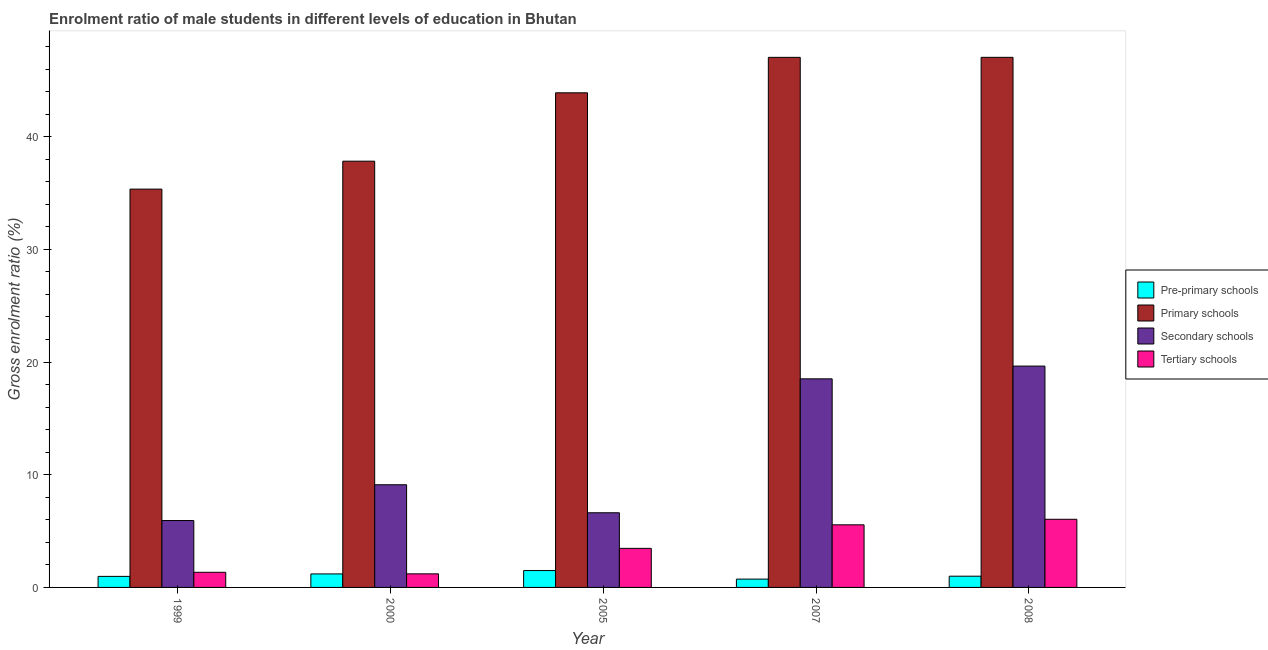How many different coloured bars are there?
Offer a terse response. 4. How many groups of bars are there?
Give a very brief answer. 5. Are the number of bars per tick equal to the number of legend labels?
Offer a terse response. Yes. Are the number of bars on each tick of the X-axis equal?
Provide a succinct answer. Yes. How many bars are there on the 5th tick from the right?
Ensure brevity in your answer.  4. What is the label of the 5th group of bars from the left?
Your response must be concise. 2008. In how many cases, is the number of bars for a given year not equal to the number of legend labels?
Offer a very short reply. 0. What is the gross enrolment ratio(female) in tertiary schools in 2005?
Keep it short and to the point. 3.47. Across all years, what is the maximum gross enrolment ratio(female) in primary schools?
Keep it short and to the point. 47.04. Across all years, what is the minimum gross enrolment ratio(female) in secondary schools?
Make the answer very short. 5.94. What is the total gross enrolment ratio(female) in tertiary schools in the graph?
Offer a terse response. 17.62. What is the difference between the gross enrolment ratio(female) in primary schools in 2005 and that in 2007?
Your response must be concise. -3.15. What is the difference between the gross enrolment ratio(female) in primary schools in 1999 and the gross enrolment ratio(female) in tertiary schools in 2000?
Your response must be concise. -2.48. What is the average gross enrolment ratio(female) in pre-primary schools per year?
Your answer should be very brief. 1.08. In the year 1999, what is the difference between the gross enrolment ratio(female) in pre-primary schools and gross enrolment ratio(female) in secondary schools?
Provide a short and direct response. 0. In how many years, is the gross enrolment ratio(female) in primary schools greater than 34 %?
Your answer should be very brief. 5. What is the ratio of the gross enrolment ratio(female) in secondary schools in 2005 to that in 2008?
Give a very brief answer. 0.34. Is the gross enrolment ratio(female) in secondary schools in 2005 less than that in 2007?
Offer a terse response. Yes. Is the difference between the gross enrolment ratio(female) in tertiary schools in 1999 and 2005 greater than the difference between the gross enrolment ratio(female) in secondary schools in 1999 and 2005?
Your answer should be compact. No. What is the difference between the highest and the second highest gross enrolment ratio(female) in pre-primary schools?
Provide a succinct answer. 0.3. What is the difference between the highest and the lowest gross enrolment ratio(female) in pre-primary schools?
Your answer should be very brief. 0.76. In how many years, is the gross enrolment ratio(female) in tertiary schools greater than the average gross enrolment ratio(female) in tertiary schools taken over all years?
Your answer should be compact. 2. Is the sum of the gross enrolment ratio(female) in primary schools in 2005 and 2008 greater than the maximum gross enrolment ratio(female) in tertiary schools across all years?
Your response must be concise. Yes. Is it the case that in every year, the sum of the gross enrolment ratio(female) in pre-primary schools and gross enrolment ratio(female) in tertiary schools is greater than the sum of gross enrolment ratio(female) in secondary schools and gross enrolment ratio(female) in primary schools?
Keep it short and to the point. No. What does the 3rd bar from the left in 1999 represents?
Offer a very short reply. Secondary schools. What does the 3rd bar from the right in 2000 represents?
Make the answer very short. Primary schools. Are all the bars in the graph horizontal?
Keep it short and to the point. No. Are the values on the major ticks of Y-axis written in scientific E-notation?
Offer a very short reply. No. Does the graph contain any zero values?
Provide a succinct answer. No. Does the graph contain grids?
Provide a short and direct response. No. How are the legend labels stacked?
Keep it short and to the point. Vertical. What is the title of the graph?
Offer a very short reply. Enrolment ratio of male students in different levels of education in Bhutan. What is the Gross enrolment ratio (%) in Pre-primary schools in 1999?
Your response must be concise. 0.98. What is the Gross enrolment ratio (%) of Primary schools in 1999?
Provide a succinct answer. 35.35. What is the Gross enrolment ratio (%) of Secondary schools in 1999?
Offer a terse response. 5.94. What is the Gross enrolment ratio (%) of Tertiary schools in 1999?
Provide a short and direct response. 1.34. What is the Gross enrolment ratio (%) of Pre-primary schools in 2000?
Provide a succinct answer. 1.2. What is the Gross enrolment ratio (%) of Primary schools in 2000?
Provide a short and direct response. 37.83. What is the Gross enrolment ratio (%) in Secondary schools in 2000?
Your response must be concise. 9.11. What is the Gross enrolment ratio (%) of Tertiary schools in 2000?
Offer a terse response. 1.2. What is the Gross enrolment ratio (%) of Pre-primary schools in 2005?
Keep it short and to the point. 1.5. What is the Gross enrolment ratio (%) of Primary schools in 2005?
Ensure brevity in your answer.  43.89. What is the Gross enrolment ratio (%) in Secondary schools in 2005?
Your answer should be very brief. 6.63. What is the Gross enrolment ratio (%) in Tertiary schools in 2005?
Your response must be concise. 3.47. What is the Gross enrolment ratio (%) in Pre-primary schools in 2007?
Provide a succinct answer. 0.74. What is the Gross enrolment ratio (%) in Primary schools in 2007?
Provide a short and direct response. 47.04. What is the Gross enrolment ratio (%) of Secondary schools in 2007?
Make the answer very short. 18.51. What is the Gross enrolment ratio (%) of Tertiary schools in 2007?
Provide a short and direct response. 5.56. What is the Gross enrolment ratio (%) in Pre-primary schools in 2008?
Provide a short and direct response. 1. What is the Gross enrolment ratio (%) of Primary schools in 2008?
Give a very brief answer. 47.04. What is the Gross enrolment ratio (%) in Secondary schools in 2008?
Provide a succinct answer. 19.64. What is the Gross enrolment ratio (%) of Tertiary schools in 2008?
Keep it short and to the point. 6.05. Across all years, what is the maximum Gross enrolment ratio (%) of Pre-primary schools?
Keep it short and to the point. 1.5. Across all years, what is the maximum Gross enrolment ratio (%) of Primary schools?
Keep it short and to the point. 47.04. Across all years, what is the maximum Gross enrolment ratio (%) of Secondary schools?
Keep it short and to the point. 19.64. Across all years, what is the maximum Gross enrolment ratio (%) of Tertiary schools?
Provide a succinct answer. 6.05. Across all years, what is the minimum Gross enrolment ratio (%) in Pre-primary schools?
Keep it short and to the point. 0.74. Across all years, what is the minimum Gross enrolment ratio (%) of Primary schools?
Ensure brevity in your answer.  35.35. Across all years, what is the minimum Gross enrolment ratio (%) in Secondary schools?
Give a very brief answer. 5.94. Across all years, what is the minimum Gross enrolment ratio (%) in Tertiary schools?
Your answer should be compact. 1.2. What is the total Gross enrolment ratio (%) of Pre-primary schools in the graph?
Offer a very short reply. 5.41. What is the total Gross enrolment ratio (%) in Primary schools in the graph?
Your answer should be compact. 211.14. What is the total Gross enrolment ratio (%) in Secondary schools in the graph?
Keep it short and to the point. 59.82. What is the total Gross enrolment ratio (%) of Tertiary schools in the graph?
Make the answer very short. 17.62. What is the difference between the Gross enrolment ratio (%) in Pre-primary schools in 1999 and that in 2000?
Provide a succinct answer. -0.22. What is the difference between the Gross enrolment ratio (%) in Primary schools in 1999 and that in 2000?
Your answer should be compact. -2.48. What is the difference between the Gross enrolment ratio (%) of Secondary schools in 1999 and that in 2000?
Your response must be concise. -3.18. What is the difference between the Gross enrolment ratio (%) of Tertiary schools in 1999 and that in 2000?
Offer a very short reply. 0.14. What is the difference between the Gross enrolment ratio (%) in Pre-primary schools in 1999 and that in 2005?
Your response must be concise. -0.52. What is the difference between the Gross enrolment ratio (%) in Primary schools in 1999 and that in 2005?
Offer a very short reply. -8.55. What is the difference between the Gross enrolment ratio (%) of Secondary schools in 1999 and that in 2005?
Give a very brief answer. -0.69. What is the difference between the Gross enrolment ratio (%) in Tertiary schools in 1999 and that in 2005?
Provide a short and direct response. -2.12. What is the difference between the Gross enrolment ratio (%) of Pre-primary schools in 1999 and that in 2007?
Your answer should be compact. 0.24. What is the difference between the Gross enrolment ratio (%) of Primary schools in 1999 and that in 2007?
Your answer should be very brief. -11.69. What is the difference between the Gross enrolment ratio (%) of Secondary schools in 1999 and that in 2007?
Your response must be concise. -12.57. What is the difference between the Gross enrolment ratio (%) in Tertiary schools in 1999 and that in 2007?
Ensure brevity in your answer.  -4.21. What is the difference between the Gross enrolment ratio (%) of Pre-primary schools in 1999 and that in 2008?
Keep it short and to the point. -0.02. What is the difference between the Gross enrolment ratio (%) of Primary schools in 1999 and that in 2008?
Your response must be concise. -11.69. What is the difference between the Gross enrolment ratio (%) in Secondary schools in 1999 and that in 2008?
Provide a succinct answer. -13.71. What is the difference between the Gross enrolment ratio (%) in Tertiary schools in 1999 and that in 2008?
Give a very brief answer. -4.71. What is the difference between the Gross enrolment ratio (%) of Pre-primary schools in 2000 and that in 2005?
Provide a succinct answer. -0.3. What is the difference between the Gross enrolment ratio (%) in Primary schools in 2000 and that in 2005?
Provide a succinct answer. -6.07. What is the difference between the Gross enrolment ratio (%) in Secondary schools in 2000 and that in 2005?
Offer a very short reply. 2.49. What is the difference between the Gross enrolment ratio (%) of Tertiary schools in 2000 and that in 2005?
Your answer should be compact. -2.26. What is the difference between the Gross enrolment ratio (%) of Pre-primary schools in 2000 and that in 2007?
Offer a very short reply. 0.46. What is the difference between the Gross enrolment ratio (%) in Primary schools in 2000 and that in 2007?
Keep it short and to the point. -9.21. What is the difference between the Gross enrolment ratio (%) in Secondary schools in 2000 and that in 2007?
Your response must be concise. -9.4. What is the difference between the Gross enrolment ratio (%) of Tertiary schools in 2000 and that in 2007?
Provide a succinct answer. -4.35. What is the difference between the Gross enrolment ratio (%) in Pre-primary schools in 2000 and that in 2008?
Your response must be concise. 0.2. What is the difference between the Gross enrolment ratio (%) of Primary schools in 2000 and that in 2008?
Your answer should be compact. -9.21. What is the difference between the Gross enrolment ratio (%) in Secondary schools in 2000 and that in 2008?
Ensure brevity in your answer.  -10.53. What is the difference between the Gross enrolment ratio (%) in Tertiary schools in 2000 and that in 2008?
Your answer should be very brief. -4.84. What is the difference between the Gross enrolment ratio (%) of Pre-primary schools in 2005 and that in 2007?
Offer a very short reply. 0.76. What is the difference between the Gross enrolment ratio (%) in Primary schools in 2005 and that in 2007?
Provide a short and direct response. -3.15. What is the difference between the Gross enrolment ratio (%) in Secondary schools in 2005 and that in 2007?
Give a very brief answer. -11.88. What is the difference between the Gross enrolment ratio (%) of Tertiary schools in 2005 and that in 2007?
Offer a very short reply. -2.09. What is the difference between the Gross enrolment ratio (%) in Pre-primary schools in 2005 and that in 2008?
Keep it short and to the point. 0.5. What is the difference between the Gross enrolment ratio (%) of Primary schools in 2005 and that in 2008?
Keep it short and to the point. -3.15. What is the difference between the Gross enrolment ratio (%) of Secondary schools in 2005 and that in 2008?
Ensure brevity in your answer.  -13.02. What is the difference between the Gross enrolment ratio (%) of Tertiary schools in 2005 and that in 2008?
Provide a short and direct response. -2.58. What is the difference between the Gross enrolment ratio (%) in Pre-primary schools in 2007 and that in 2008?
Your response must be concise. -0.26. What is the difference between the Gross enrolment ratio (%) of Primary schools in 2007 and that in 2008?
Your answer should be very brief. -0. What is the difference between the Gross enrolment ratio (%) in Secondary schools in 2007 and that in 2008?
Your response must be concise. -1.13. What is the difference between the Gross enrolment ratio (%) of Tertiary schools in 2007 and that in 2008?
Provide a succinct answer. -0.49. What is the difference between the Gross enrolment ratio (%) in Pre-primary schools in 1999 and the Gross enrolment ratio (%) in Primary schools in 2000?
Your response must be concise. -36.84. What is the difference between the Gross enrolment ratio (%) of Pre-primary schools in 1999 and the Gross enrolment ratio (%) of Secondary schools in 2000?
Your answer should be very brief. -8.13. What is the difference between the Gross enrolment ratio (%) in Pre-primary schools in 1999 and the Gross enrolment ratio (%) in Tertiary schools in 2000?
Your answer should be very brief. -0.22. What is the difference between the Gross enrolment ratio (%) in Primary schools in 1999 and the Gross enrolment ratio (%) in Secondary schools in 2000?
Offer a very short reply. 26.23. What is the difference between the Gross enrolment ratio (%) in Primary schools in 1999 and the Gross enrolment ratio (%) in Tertiary schools in 2000?
Keep it short and to the point. 34.14. What is the difference between the Gross enrolment ratio (%) of Secondary schools in 1999 and the Gross enrolment ratio (%) of Tertiary schools in 2000?
Ensure brevity in your answer.  4.73. What is the difference between the Gross enrolment ratio (%) in Pre-primary schools in 1999 and the Gross enrolment ratio (%) in Primary schools in 2005?
Ensure brevity in your answer.  -42.91. What is the difference between the Gross enrolment ratio (%) in Pre-primary schools in 1999 and the Gross enrolment ratio (%) in Secondary schools in 2005?
Your answer should be very brief. -5.65. What is the difference between the Gross enrolment ratio (%) of Pre-primary schools in 1999 and the Gross enrolment ratio (%) of Tertiary schools in 2005?
Give a very brief answer. -2.49. What is the difference between the Gross enrolment ratio (%) in Primary schools in 1999 and the Gross enrolment ratio (%) in Secondary schools in 2005?
Give a very brief answer. 28.72. What is the difference between the Gross enrolment ratio (%) of Primary schools in 1999 and the Gross enrolment ratio (%) of Tertiary schools in 2005?
Offer a terse response. 31.88. What is the difference between the Gross enrolment ratio (%) of Secondary schools in 1999 and the Gross enrolment ratio (%) of Tertiary schools in 2005?
Your answer should be compact. 2.47. What is the difference between the Gross enrolment ratio (%) of Pre-primary schools in 1999 and the Gross enrolment ratio (%) of Primary schools in 2007?
Your answer should be compact. -46.06. What is the difference between the Gross enrolment ratio (%) of Pre-primary schools in 1999 and the Gross enrolment ratio (%) of Secondary schools in 2007?
Keep it short and to the point. -17.53. What is the difference between the Gross enrolment ratio (%) of Pre-primary schools in 1999 and the Gross enrolment ratio (%) of Tertiary schools in 2007?
Ensure brevity in your answer.  -4.58. What is the difference between the Gross enrolment ratio (%) of Primary schools in 1999 and the Gross enrolment ratio (%) of Secondary schools in 2007?
Your answer should be compact. 16.84. What is the difference between the Gross enrolment ratio (%) of Primary schools in 1999 and the Gross enrolment ratio (%) of Tertiary schools in 2007?
Ensure brevity in your answer.  29.79. What is the difference between the Gross enrolment ratio (%) in Secondary schools in 1999 and the Gross enrolment ratio (%) in Tertiary schools in 2007?
Provide a short and direct response. 0.38. What is the difference between the Gross enrolment ratio (%) in Pre-primary schools in 1999 and the Gross enrolment ratio (%) in Primary schools in 2008?
Offer a very short reply. -46.06. What is the difference between the Gross enrolment ratio (%) in Pre-primary schools in 1999 and the Gross enrolment ratio (%) in Secondary schools in 2008?
Your answer should be compact. -18.66. What is the difference between the Gross enrolment ratio (%) of Pre-primary schools in 1999 and the Gross enrolment ratio (%) of Tertiary schools in 2008?
Offer a terse response. -5.07. What is the difference between the Gross enrolment ratio (%) of Primary schools in 1999 and the Gross enrolment ratio (%) of Secondary schools in 2008?
Keep it short and to the point. 15.7. What is the difference between the Gross enrolment ratio (%) in Primary schools in 1999 and the Gross enrolment ratio (%) in Tertiary schools in 2008?
Provide a short and direct response. 29.3. What is the difference between the Gross enrolment ratio (%) in Secondary schools in 1999 and the Gross enrolment ratio (%) in Tertiary schools in 2008?
Make the answer very short. -0.11. What is the difference between the Gross enrolment ratio (%) in Pre-primary schools in 2000 and the Gross enrolment ratio (%) in Primary schools in 2005?
Your response must be concise. -42.69. What is the difference between the Gross enrolment ratio (%) in Pre-primary schools in 2000 and the Gross enrolment ratio (%) in Secondary schools in 2005?
Keep it short and to the point. -5.43. What is the difference between the Gross enrolment ratio (%) of Pre-primary schools in 2000 and the Gross enrolment ratio (%) of Tertiary schools in 2005?
Provide a succinct answer. -2.27. What is the difference between the Gross enrolment ratio (%) in Primary schools in 2000 and the Gross enrolment ratio (%) in Secondary schools in 2005?
Your answer should be very brief. 31.2. What is the difference between the Gross enrolment ratio (%) in Primary schools in 2000 and the Gross enrolment ratio (%) in Tertiary schools in 2005?
Offer a terse response. 34.36. What is the difference between the Gross enrolment ratio (%) in Secondary schools in 2000 and the Gross enrolment ratio (%) in Tertiary schools in 2005?
Offer a very short reply. 5.65. What is the difference between the Gross enrolment ratio (%) in Pre-primary schools in 2000 and the Gross enrolment ratio (%) in Primary schools in 2007?
Your response must be concise. -45.84. What is the difference between the Gross enrolment ratio (%) in Pre-primary schools in 2000 and the Gross enrolment ratio (%) in Secondary schools in 2007?
Offer a very short reply. -17.31. What is the difference between the Gross enrolment ratio (%) in Pre-primary schools in 2000 and the Gross enrolment ratio (%) in Tertiary schools in 2007?
Provide a succinct answer. -4.36. What is the difference between the Gross enrolment ratio (%) in Primary schools in 2000 and the Gross enrolment ratio (%) in Secondary schools in 2007?
Your answer should be compact. 19.32. What is the difference between the Gross enrolment ratio (%) of Primary schools in 2000 and the Gross enrolment ratio (%) of Tertiary schools in 2007?
Your answer should be compact. 32.27. What is the difference between the Gross enrolment ratio (%) of Secondary schools in 2000 and the Gross enrolment ratio (%) of Tertiary schools in 2007?
Keep it short and to the point. 3.56. What is the difference between the Gross enrolment ratio (%) of Pre-primary schools in 2000 and the Gross enrolment ratio (%) of Primary schools in 2008?
Give a very brief answer. -45.84. What is the difference between the Gross enrolment ratio (%) of Pre-primary schools in 2000 and the Gross enrolment ratio (%) of Secondary schools in 2008?
Offer a terse response. -18.44. What is the difference between the Gross enrolment ratio (%) of Pre-primary schools in 2000 and the Gross enrolment ratio (%) of Tertiary schools in 2008?
Offer a terse response. -4.85. What is the difference between the Gross enrolment ratio (%) in Primary schools in 2000 and the Gross enrolment ratio (%) in Secondary schools in 2008?
Your answer should be very brief. 18.18. What is the difference between the Gross enrolment ratio (%) of Primary schools in 2000 and the Gross enrolment ratio (%) of Tertiary schools in 2008?
Provide a succinct answer. 31.78. What is the difference between the Gross enrolment ratio (%) of Secondary schools in 2000 and the Gross enrolment ratio (%) of Tertiary schools in 2008?
Give a very brief answer. 3.06. What is the difference between the Gross enrolment ratio (%) in Pre-primary schools in 2005 and the Gross enrolment ratio (%) in Primary schools in 2007?
Provide a short and direct response. -45.54. What is the difference between the Gross enrolment ratio (%) of Pre-primary schools in 2005 and the Gross enrolment ratio (%) of Secondary schools in 2007?
Provide a succinct answer. -17.01. What is the difference between the Gross enrolment ratio (%) in Pre-primary schools in 2005 and the Gross enrolment ratio (%) in Tertiary schools in 2007?
Your answer should be very brief. -4.06. What is the difference between the Gross enrolment ratio (%) of Primary schools in 2005 and the Gross enrolment ratio (%) of Secondary schools in 2007?
Your answer should be compact. 25.38. What is the difference between the Gross enrolment ratio (%) of Primary schools in 2005 and the Gross enrolment ratio (%) of Tertiary schools in 2007?
Ensure brevity in your answer.  38.34. What is the difference between the Gross enrolment ratio (%) in Secondary schools in 2005 and the Gross enrolment ratio (%) in Tertiary schools in 2007?
Make the answer very short. 1.07. What is the difference between the Gross enrolment ratio (%) of Pre-primary schools in 2005 and the Gross enrolment ratio (%) of Primary schools in 2008?
Provide a short and direct response. -45.54. What is the difference between the Gross enrolment ratio (%) in Pre-primary schools in 2005 and the Gross enrolment ratio (%) in Secondary schools in 2008?
Make the answer very short. -18.14. What is the difference between the Gross enrolment ratio (%) in Pre-primary schools in 2005 and the Gross enrolment ratio (%) in Tertiary schools in 2008?
Your response must be concise. -4.55. What is the difference between the Gross enrolment ratio (%) of Primary schools in 2005 and the Gross enrolment ratio (%) of Secondary schools in 2008?
Your answer should be very brief. 24.25. What is the difference between the Gross enrolment ratio (%) in Primary schools in 2005 and the Gross enrolment ratio (%) in Tertiary schools in 2008?
Offer a terse response. 37.84. What is the difference between the Gross enrolment ratio (%) in Secondary schools in 2005 and the Gross enrolment ratio (%) in Tertiary schools in 2008?
Provide a succinct answer. 0.58. What is the difference between the Gross enrolment ratio (%) in Pre-primary schools in 2007 and the Gross enrolment ratio (%) in Primary schools in 2008?
Make the answer very short. -46.3. What is the difference between the Gross enrolment ratio (%) in Pre-primary schools in 2007 and the Gross enrolment ratio (%) in Secondary schools in 2008?
Provide a succinct answer. -18.9. What is the difference between the Gross enrolment ratio (%) of Pre-primary schools in 2007 and the Gross enrolment ratio (%) of Tertiary schools in 2008?
Ensure brevity in your answer.  -5.31. What is the difference between the Gross enrolment ratio (%) in Primary schools in 2007 and the Gross enrolment ratio (%) in Secondary schools in 2008?
Provide a succinct answer. 27.4. What is the difference between the Gross enrolment ratio (%) of Primary schools in 2007 and the Gross enrolment ratio (%) of Tertiary schools in 2008?
Provide a short and direct response. 40.99. What is the difference between the Gross enrolment ratio (%) of Secondary schools in 2007 and the Gross enrolment ratio (%) of Tertiary schools in 2008?
Offer a very short reply. 12.46. What is the average Gross enrolment ratio (%) of Pre-primary schools per year?
Your answer should be compact. 1.08. What is the average Gross enrolment ratio (%) in Primary schools per year?
Provide a succinct answer. 42.23. What is the average Gross enrolment ratio (%) of Secondary schools per year?
Your answer should be very brief. 11.96. What is the average Gross enrolment ratio (%) of Tertiary schools per year?
Offer a terse response. 3.52. In the year 1999, what is the difference between the Gross enrolment ratio (%) in Pre-primary schools and Gross enrolment ratio (%) in Primary schools?
Provide a succinct answer. -34.37. In the year 1999, what is the difference between the Gross enrolment ratio (%) in Pre-primary schools and Gross enrolment ratio (%) in Secondary schools?
Give a very brief answer. -4.96. In the year 1999, what is the difference between the Gross enrolment ratio (%) in Pre-primary schools and Gross enrolment ratio (%) in Tertiary schools?
Keep it short and to the point. -0.36. In the year 1999, what is the difference between the Gross enrolment ratio (%) of Primary schools and Gross enrolment ratio (%) of Secondary schools?
Your answer should be very brief. 29.41. In the year 1999, what is the difference between the Gross enrolment ratio (%) in Primary schools and Gross enrolment ratio (%) in Tertiary schools?
Ensure brevity in your answer.  34. In the year 1999, what is the difference between the Gross enrolment ratio (%) in Secondary schools and Gross enrolment ratio (%) in Tertiary schools?
Your answer should be very brief. 4.59. In the year 2000, what is the difference between the Gross enrolment ratio (%) of Pre-primary schools and Gross enrolment ratio (%) of Primary schools?
Offer a very short reply. -36.63. In the year 2000, what is the difference between the Gross enrolment ratio (%) in Pre-primary schools and Gross enrolment ratio (%) in Secondary schools?
Offer a very short reply. -7.91. In the year 2000, what is the difference between the Gross enrolment ratio (%) in Pre-primary schools and Gross enrolment ratio (%) in Tertiary schools?
Provide a succinct answer. -0.01. In the year 2000, what is the difference between the Gross enrolment ratio (%) in Primary schools and Gross enrolment ratio (%) in Secondary schools?
Offer a terse response. 28.71. In the year 2000, what is the difference between the Gross enrolment ratio (%) in Primary schools and Gross enrolment ratio (%) in Tertiary schools?
Your answer should be compact. 36.62. In the year 2000, what is the difference between the Gross enrolment ratio (%) of Secondary schools and Gross enrolment ratio (%) of Tertiary schools?
Keep it short and to the point. 7.91. In the year 2005, what is the difference between the Gross enrolment ratio (%) of Pre-primary schools and Gross enrolment ratio (%) of Primary schools?
Give a very brief answer. -42.39. In the year 2005, what is the difference between the Gross enrolment ratio (%) of Pre-primary schools and Gross enrolment ratio (%) of Secondary schools?
Provide a succinct answer. -5.13. In the year 2005, what is the difference between the Gross enrolment ratio (%) of Pre-primary schools and Gross enrolment ratio (%) of Tertiary schools?
Provide a succinct answer. -1.97. In the year 2005, what is the difference between the Gross enrolment ratio (%) in Primary schools and Gross enrolment ratio (%) in Secondary schools?
Make the answer very short. 37.27. In the year 2005, what is the difference between the Gross enrolment ratio (%) of Primary schools and Gross enrolment ratio (%) of Tertiary schools?
Your answer should be compact. 40.43. In the year 2005, what is the difference between the Gross enrolment ratio (%) in Secondary schools and Gross enrolment ratio (%) in Tertiary schools?
Ensure brevity in your answer.  3.16. In the year 2007, what is the difference between the Gross enrolment ratio (%) in Pre-primary schools and Gross enrolment ratio (%) in Primary schools?
Your response must be concise. -46.3. In the year 2007, what is the difference between the Gross enrolment ratio (%) of Pre-primary schools and Gross enrolment ratio (%) of Secondary schools?
Provide a short and direct response. -17.77. In the year 2007, what is the difference between the Gross enrolment ratio (%) in Pre-primary schools and Gross enrolment ratio (%) in Tertiary schools?
Offer a very short reply. -4.82. In the year 2007, what is the difference between the Gross enrolment ratio (%) of Primary schools and Gross enrolment ratio (%) of Secondary schools?
Offer a terse response. 28.53. In the year 2007, what is the difference between the Gross enrolment ratio (%) in Primary schools and Gross enrolment ratio (%) in Tertiary schools?
Give a very brief answer. 41.48. In the year 2007, what is the difference between the Gross enrolment ratio (%) in Secondary schools and Gross enrolment ratio (%) in Tertiary schools?
Offer a very short reply. 12.95. In the year 2008, what is the difference between the Gross enrolment ratio (%) of Pre-primary schools and Gross enrolment ratio (%) of Primary schools?
Keep it short and to the point. -46.04. In the year 2008, what is the difference between the Gross enrolment ratio (%) in Pre-primary schools and Gross enrolment ratio (%) in Secondary schools?
Provide a short and direct response. -18.64. In the year 2008, what is the difference between the Gross enrolment ratio (%) in Pre-primary schools and Gross enrolment ratio (%) in Tertiary schools?
Your response must be concise. -5.05. In the year 2008, what is the difference between the Gross enrolment ratio (%) of Primary schools and Gross enrolment ratio (%) of Secondary schools?
Your response must be concise. 27.4. In the year 2008, what is the difference between the Gross enrolment ratio (%) of Primary schools and Gross enrolment ratio (%) of Tertiary schools?
Your answer should be compact. 40.99. In the year 2008, what is the difference between the Gross enrolment ratio (%) of Secondary schools and Gross enrolment ratio (%) of Tertiary schools?
Your answer should be very brief. 13.59. What is the ratio of the Gross enrolment ratio (%) in Pre-primary schools in 1999 to that in 2000?
Offer a terse response. 0.82. What is the ratio of the Gross enrolment ratio (%) in Primary schools in 1999 to that in 2000?
Offer a terse response. 0.93. What is the ratio of the Gross enrolment ratio (%) of Secondary schools in 1999 to that in 2000?
Provide a succinct answer. 0.65. What is the ratio of the Gross enrolment ratio (%) of Tertiary schools in 1999 to that in 2000?
Ensure brevity in your answer.  1.11. What is the ratio of the Gross enrolment ratio (%) of Pre-primary schools in 1999 to that in 2005?
Your answer should be very brief. 0.65. What is the ratio of the Gross enrolment ratio (%) of Primary schools in 1999 to that in 2005?
Make the answer very short. 0.81. What is the ratio of the Gross enrolment ratio (%) in Secondary schools in 1999 to that in 2005?
Your answer should be very brief. 0.9. What is the ratio of the Gross enrolment ratio (%) in Tertiary schools in 1999 to that in 2005?
Your response must be concise. 0.39. What is the ratio of the Gross enrolment ratio (%) of Pre-primary schools in 1999 to that in 2007?
Provide a succinct answer. 1.33. What is the ratio of the Gross enrolment ratio (%) of Primary schools in 1999 to that in 2007?
Your response must be concise. 0.75. What is the ratio of the Gross enrolment ratio (%) of Secondary schools in 1999 to that in 2007?
Keep it short and to the point. 0.32. What is the ratio of the Gross enrolment ratio (%) in Tertiary schools in 1999 to that in 2007?
Your answer should be compact. 0.24. What is the ratio of the Gross enrolment ratio (%) in Pre-primary schools in 1999 to that in 2008?
Your answer should be very brief. 0.98. What is the ratio of the Gross enrolment ratio (%) of Primary schools in 1999 to that in 2008?
Provide a short and direct response. 0.75. What is the ratio of the Gross enrolment ratio (%) in Secondary schools in 1999 to that in 2008?
Your answer should be very brief. 0.3. What is the ratio of the Gross enrolment ratio (%) of Tertiary schools in 1999 to that in 2008?
Your answer should be very brief. 0.22. What is the ratio of the Gross enrolment ratio (%) of Pre-primary schools in 2000 to that in 2005?
Keep it short and to the point. 0.8. What is the ratio of the Gross enrolment ratio (%) of Primary schools in 2000 to that in 2005?
Your answer should be compact. 0.86. What is the ratio of the Gross enrolment ratio (%) in Secondary schools in 2000 to that in 2005?
Make the answer very short. 1.38. What is the ratio of the Gross enrolment ratio (%) of Tertiary schools in 2000 to that in 2005?
Give a very brief answer. 0.35. What is the ratio of the Gross enrolment ratio (%) of Pre-primary schools in 2000 to that in 2007?
Give a very brief answer. 1.62. What is the ratio of the Gross enrolment ratio (%) in Primary schools in 2000 to that in 2007?
Give a very brief answer. 0.8. What is the ratio of the Gross enrolment ratio (%) in Secondary schools in 2000 to that in 2007?
Keep it short and to the point. 0.49. What is the ratio of the Gross enrolment ratio (%) of Tertiary schools in 2000 to that in 2007?
Keep it short and to the point. 0.22. What is the ratio of the Gross enrolment ratio (%) of Pre-primary schools in 2000 to that in 2008?
Your response must be concise. 1.2. What is the ratio of the Gross enrolment ratio (%) in Primary schools in 2000 to that in 2008?
Keep it short and to the point. 0.8. What is the ratio of the Gross enrolment ratio (%) in Secondary schools in 2000 to that in 2008?
Make the answer very short. 0.46. What is the ratio of the Gross enrolment ratio (%) in Tertiary schools in 2000 to that in 2008?
Provide a short and direct response. 0.2. What is the ratio of the Gross enrolment ratio (%) in Pre-primary schools in 2005 to that in 2007?
Ensure brevity in your answer.  2.03. What is the ratio of the Gross enrolment ratio (%) of Primary schools in 2005 to that in 2007?
Offer a terse response. 0.93. What is the ratio of the Gross enrolment ratio (%) in Secondary schools in 2005 to that in 2007?
Your answer should be compact. 0.36. What is the ratio of the Gross enrolment ratio (%) in Tertiary schools in 2005 to that in 2007?
Make the answer very short. 0.62. What is the ratio of the Gross enrolment ratio (%) of Pre-primary schools in 2005 to that in 2008?
Ensure brevity in your answer.  1.5. What is the ratio of the Gross enrolment ratio (%) of Primary schools in 2005 to that in 2008?
Offer a very short reply. 0.93. What is the ratio of the Gross enrolment ratio (%) of Secondary schools in 2005 to that in 2008?
Make the answer very short. 0.34. What is the ratio of the Gross enrolment ratio (%) in Tertiary schools in 2005 to that in 2008?
Provide a succinct answer. 0.57. What is the ratio of the Gross enrolment ratio (%) in Pre-primary schools in 2007 to that in 2008?
Provide a short and direct response. 0.74. What is the ratio of the Gross enrolment ratio (%) of Secondary schools in 2007 to that in 2008?
Your answer should be compact. 0.94. What is the ratio of the Gross enrolment ratio (%) of Tertiary schools in 2007 to that in 2008?
Offer a terse response. 0.92. What is the difference between the highest and the second highest Gross enrolment ratio (%) of Pre-primary schools?
Offer a terse response. 0.3. What is the difference between the highest and the second highest Gross enrolment ratio (%) in Primary schools?
Your answer should be compact. 0. What is the difference between the highest and the second highest Gross enrolment ratio (%) of Secondary schools?
Make the answer very short. 1.13. What is the difference between the highest and the second highest Gross enrolment ratio (%) in Tertiary schools?
Give a very brief answer. 0.49. What is the difference between the highest and the lowest Gross enrolment ratio (%) in Pre-primary schools?
Provide a succinct answer. 0.76. What is the difference between the highest and the lowest Gross enrolment ratio (%) of Primary schools?
Make the answer very short. 11.69. What is the difference between the highest and the lowest Gross enrolment ratio (%) in Secondary schools?
Your answer should be compact. 13.71. What is the difference between the highest and the lowest Gross enrolment ratio (%) of Tertiary schools?
Ensure brevity in your answer.  4.84. 